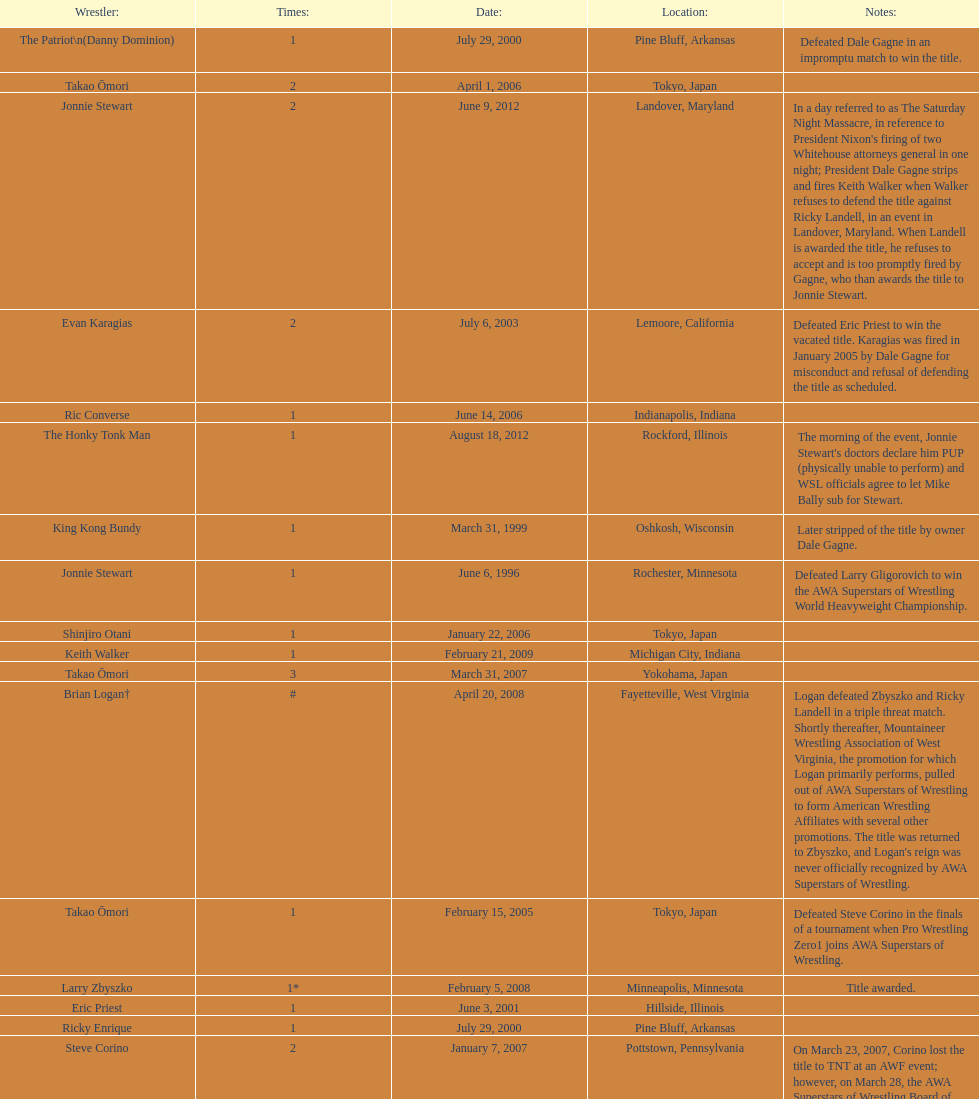When did steve corino win his first wsl title? June 11, 2005. 